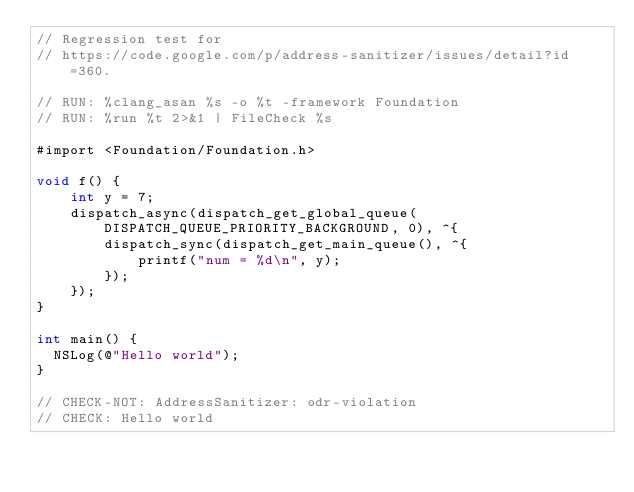Convert code to text. <code><loc_0><loc_0><loc_500><loc_500><_ObjectiveC_>// Regression test for
// https://code.google.com/p/address-sanitizer/issues/detail?id=360.

// RUN: %clang_asan %s -o %t -framework Foundation
// RUN: %run %t 2>&1 | FileCheck %s

#import <Foundation/Foundation.h>

void f() {
    int y = 7;
    dispatch_async(dispatch_get_global_queue(DISPATCH_QUEUE_PRIORITY_BACKGROUND, 0), ^{
        dispatch_sync(dispatch_get_main_queue(), ^{
            printf("num = %d\n", y);
        });
    });
}

int main() {
  NSLog(@"Hello world");
}

// CHECK-NOT: AddressSanitizer: odr-violation
// CHECK: Hello world
</code> 